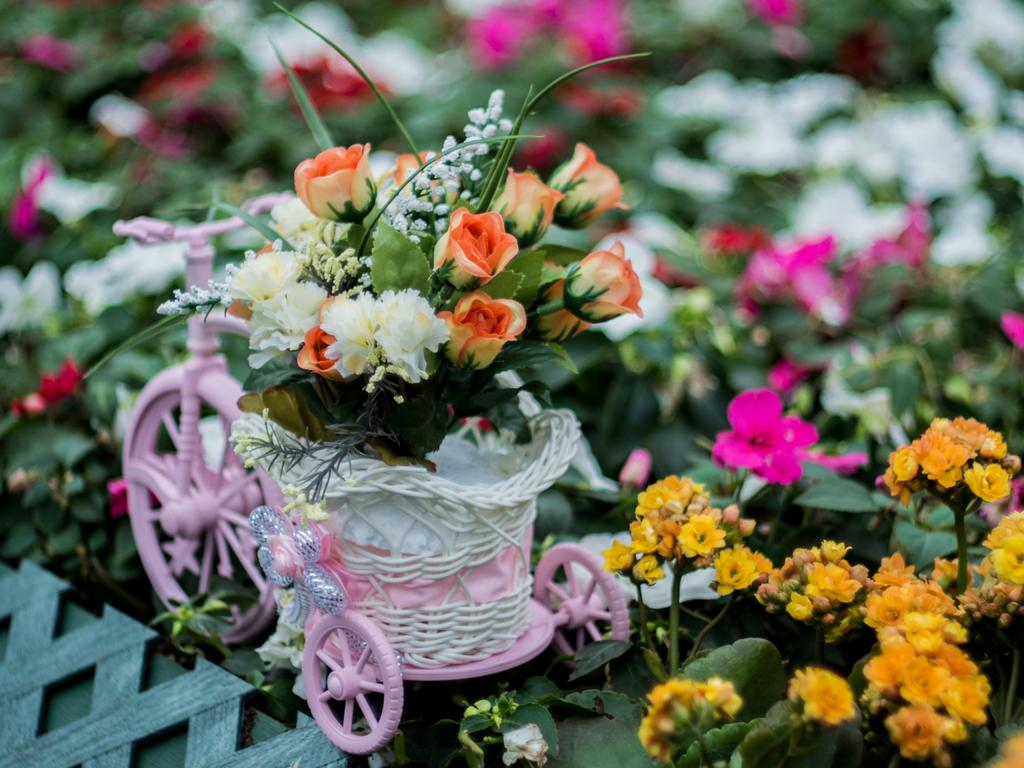What can be found in the bottom right corner of the image? There are flowers in the bottom right of the image. What is the main object in the middle of the image? There is a cycle in the middle of the image. What type of flowers are present in the cycle? The cycle contains roses. What type of noise can be heard coming from the flowers in the image? There is no noise coming from the flowers in the image, as they are not capable of producing sound. What is the purpose of the cycle in the image? The purpose of the cycle in the image is not explicitly stated, but it may be for decorative or artistic purposes. 